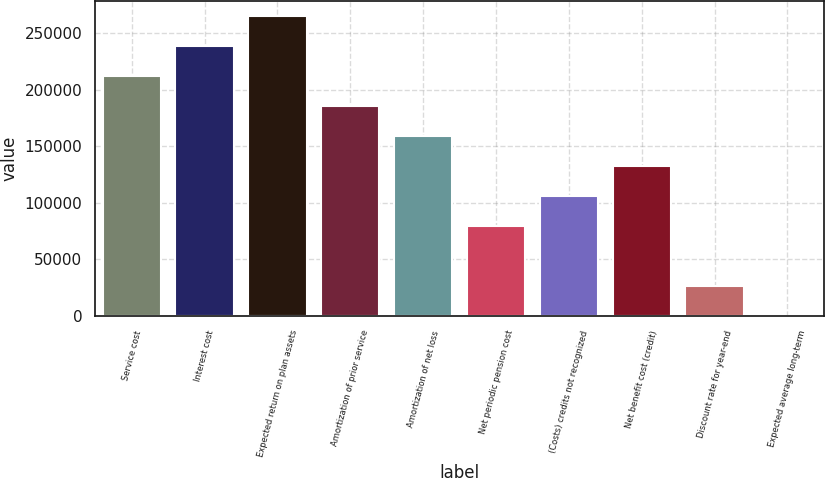Convert chart to OTSL. <chart><loc_0><loc_0><loc_500><loc_500><bar_chart><fcel>Service cost<fcel>Interest cost<fcel>Expected return on plan assets<fcel>Amortization of prior service<fcel>Amortization of net loss<fcel>Net periodic pension cost<fcel>(Costs) credits not recognized<fcel>Net benefit cost (credit)<fcel>Discount rate for year-end<fcel>Expected average long-term<nl><fcel>211866<fcel>238348<fcel>264831<fcel>185383<fcel>158900<fcel>79452.1<fcel>105935<fcel>132418<fcel>26486.7<fcel>4<nl></chart> 